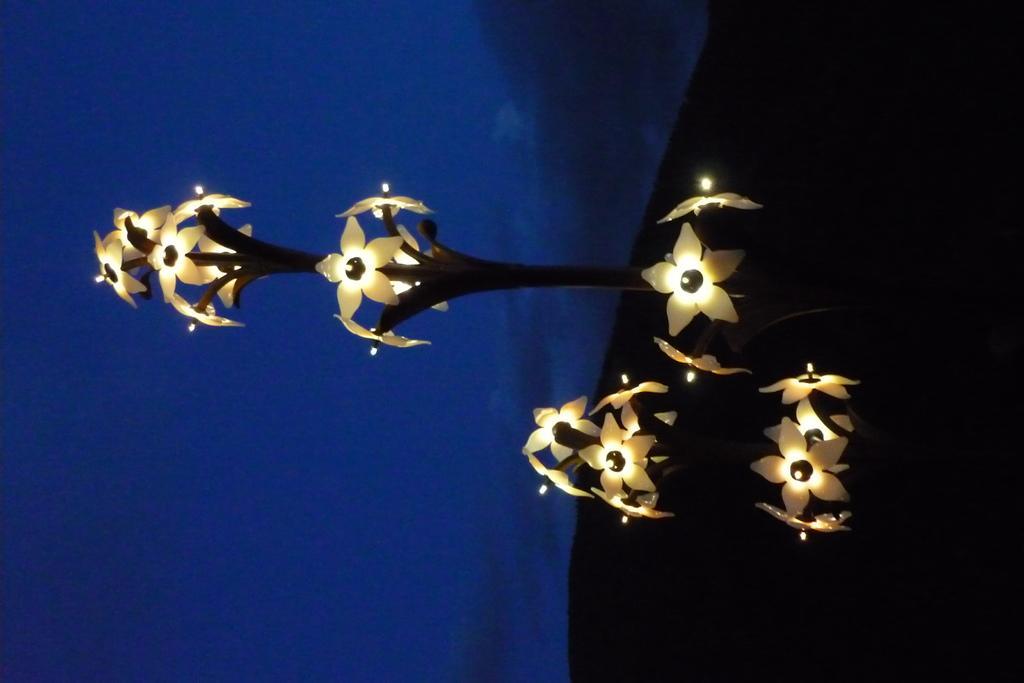In one or two sentences, can you explain what this image depicts? On the right side, there is an artificial plant having artificial flowers. In the background, there are clouds in the blue sky. 